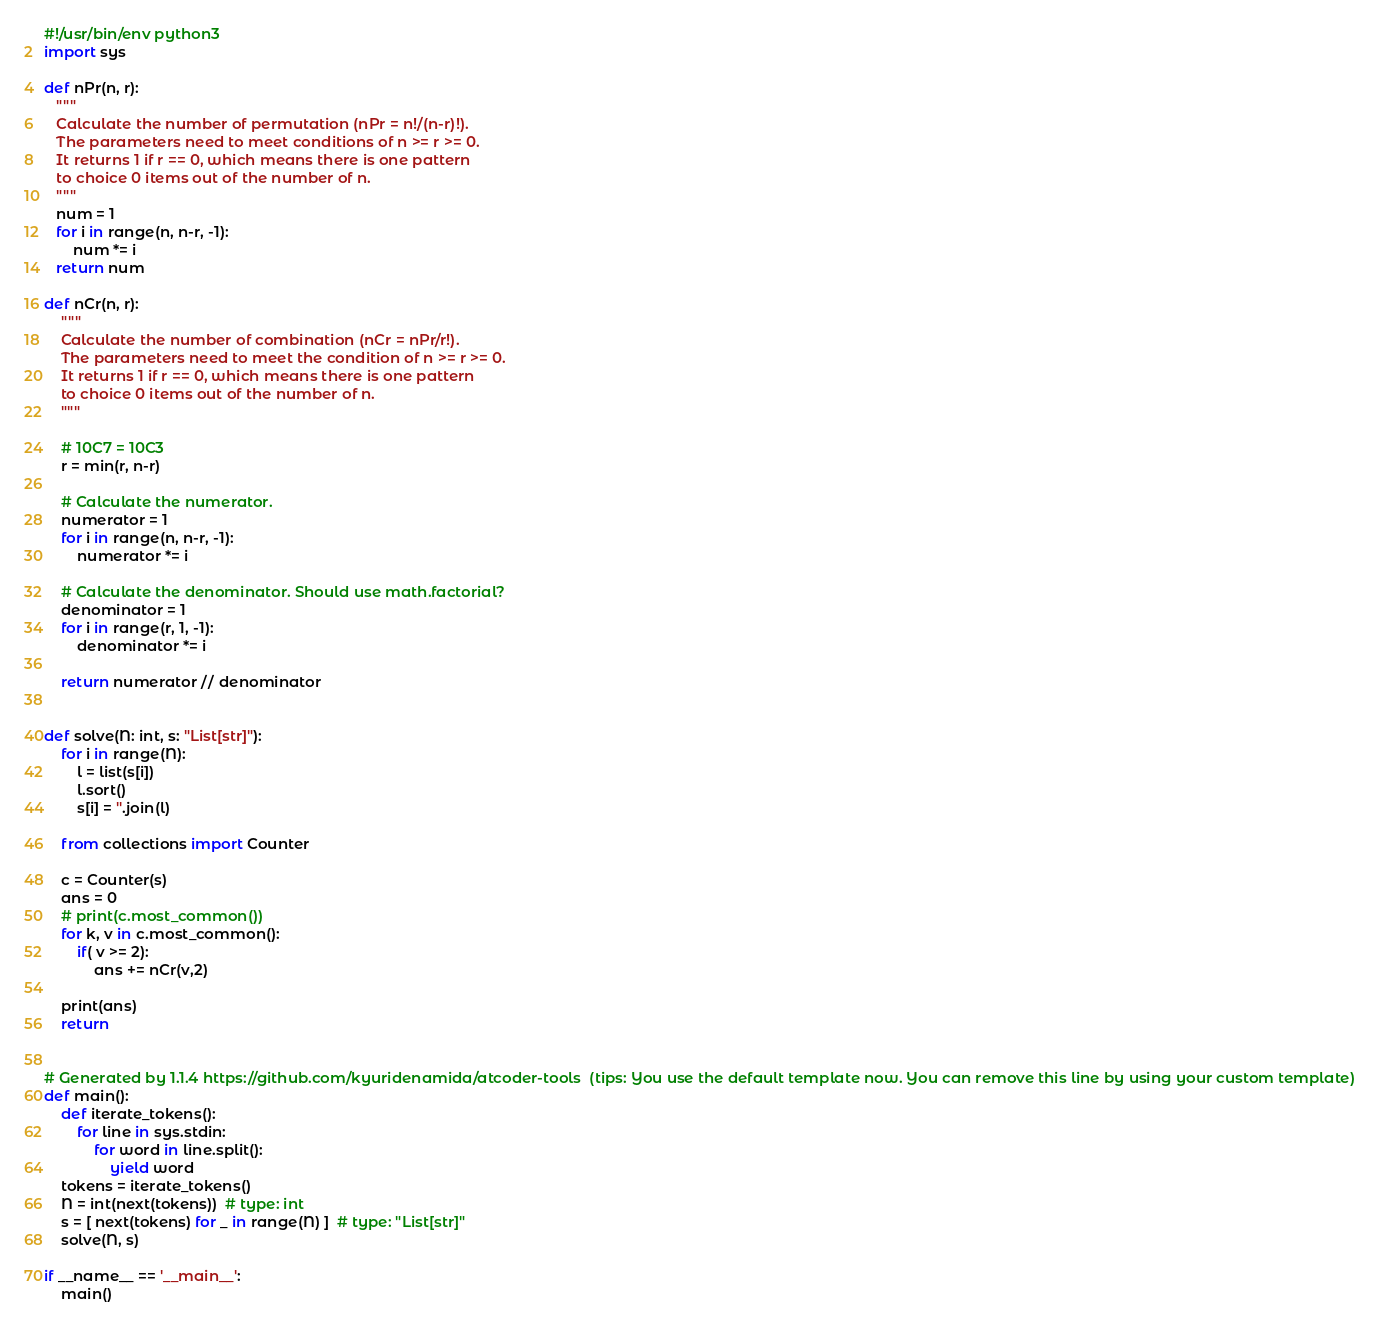<code> <loc_0><loc_0><loc_500><loc_500><_Python_>#!/usr/bin/env python3
import sys

def nPr(n, r):
   """
   Calculate the number of permutation (nPr = n!/(n-r)!).
   The parameters need to meet conditions of n >= r >= 0.
   It returns 1 if r == 0, which means there is one pattern
   to choice 0 items out of the number of n.
   """
   num = 1
   for i in range(n, n-r, -1):
       num *= i
   return num

def nCr(n, r):
    """
    Calculate the number of combination (nCr = nPr/r!).
    The parameters need to meet the condition of n >= r >= 0.
    It returns 1 if r == 0, which means there is one pattern
    to choice 0 items out of the number of n.
    """

    # 10C7 = 10C3
    r = min(r, n-r)

    # Calculate the numerator.
    numerator = 1
    for i in range(n, n-r, -1):
        numerator *= i

    # Calculate the denominator. Should use math.factorial?
    denominator = 1
    for i in range(r, 1, -1):
        denominator *= i

    return numerator // denominator


def solve(N: int, s: "List[str]"):
    for i in range(N):
        l = list(s[i])
        l.sort()
        s[i] = ''.join(l)

    from collections import Counter

    c = Counter(s)
    ans = 0
    # print(c.most_common())
    for k, v in c.most_common():
        if( v >= 2):
            ans += nCr(v,2)

    print(ans)
    return


# Generated by 1.1.4 https://github.com/kyuridenamida/atcoder-tools  (tips: You use the default template now. You can remove this line by using your custom template)
def main():
    def iterate_tokens():
        for line in sys.stdin:
            for word in line.split():
                yield word
    tokens = iterate_tokens()
    N = int(next(tokens))  # type: int
    s = [ next(tokens) for _ in range(N) ]  # type: "List[str]"
    solve(N, s)

if __name__ == '__main__':
    main()
</code> 